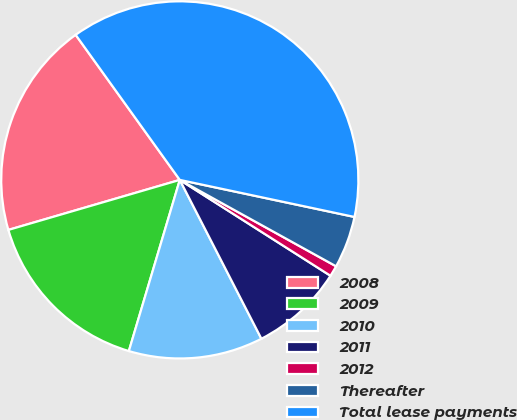<chart> <loc_0><loc_0><loc_500><loc_500><pie_chart><fcel>2008<fcel>2009<fcel>2010<fcel>2011<fcel>2012<fcel>Thereafter<fcel>Total lease payments<nl><fcel>19.61%<fcel>15.88%<fcel>12.16%<fcel>8.43%<fcel>0.98%<fcel>4.71%<fcel>38.24%<nl></chart> 